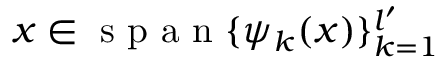<formula> <loc_0><loc_0><loc_500><loc_500>x \in s p a n \{ \psi _ { k } ( x ) \} _ { k = 1 } ^ { l ^ { \prime } }</formula> 